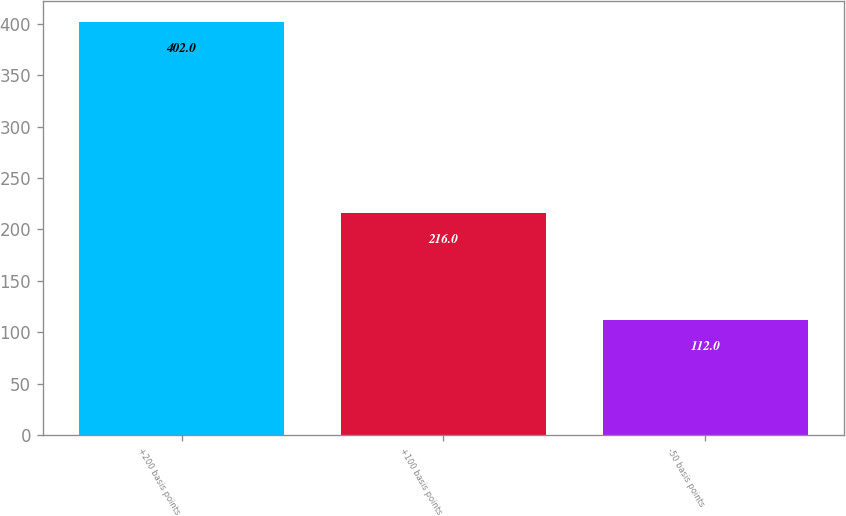<chart> <loc_0><loc_0><loc_500><loc_500><bar_chart><fcel>+200 basis points<fcel>+100 basis points<fcel>-50 basis points<nl><fcel>402<fcel>216<fcel>112<nl></chart> 